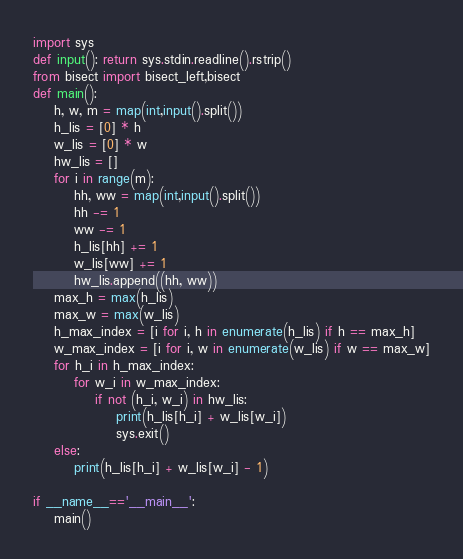Convert code to text. <code><loc_0><loc_0><loc_500><loc_500><_Python_>import sys
def input(): return sys.stdin.readline().rstrip()
from bisect import bisect_left,bisect
def main():
    h, w, m = map(int,input().split()) 
    h_lis = [0] * h
    w_lis = [0] * w
    hw_lis = [] 
    for i in range(m):
        hh, ww = map(int,input().split())
        hh -= 1
        ww -= 1
        h_lis[hh] += 1
        w_lis[ww] += 1
        hw_lis.append((hh, ww))
    max_h = max(h_lis)
    max_w = max(w_lis)
    h_max_index = [i for i, h in enumerate(h_lis) if h == max_h]
    w_max_index = [i for i, w in enumerate(w_lis) if w == max_w]
    for h_i in h_max_index:
        for w_i in w_max_index:
            if not (h_i, w_i) in hw_lis:
                print(h_lis[h_i] + w_lis[w_i])
                sys.exit()
    else:
        print(h_lis[h_i] + w_lis[w_i] - 1)

if __name__=='__main__':
    main()</code> 